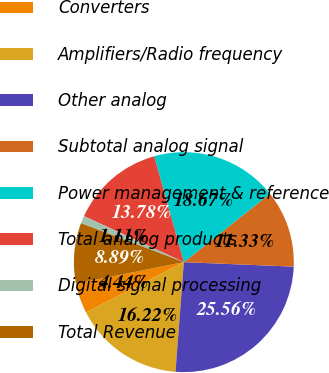Convert chart. <chart><loc_0><loc_0><loc_500><loc_500><pie_chart><fcel>Converters<fcel>Amplifiers/Radio frequency<fcel>Other analog<fcel>Subtotal analog signal<fcel>Power management & reference<fcel>Total analog products<fcel>Digital signal processing<fcel>Total Revenue<nl><fcel>4.44%<fcel>16.22%<fcel>25.56%<fcel>11.33%<fcel>18.67%<fcel>13.78%<fcel>1.11%<fcel>8.89%<nl></chart> 